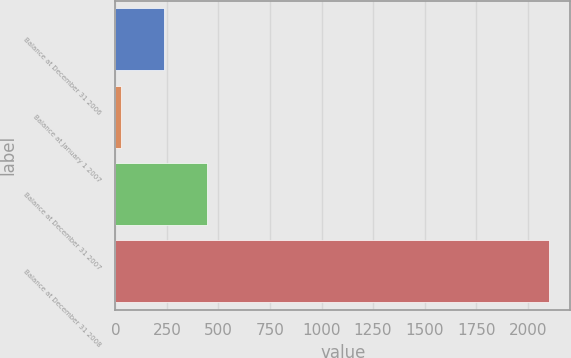Convert chart. <chart><loc_0><loc_0><loc_500><loc_500><bar_chart><fcel>Balance at December 31 2006<fcel>Balance at January 1 2007<fcel>Balance at December 31 2007<fcel>Balance at December 31 2008<nl><fcel>235.3<fcel>28<fcel>442.6<fcel>2101<nl></chart> 